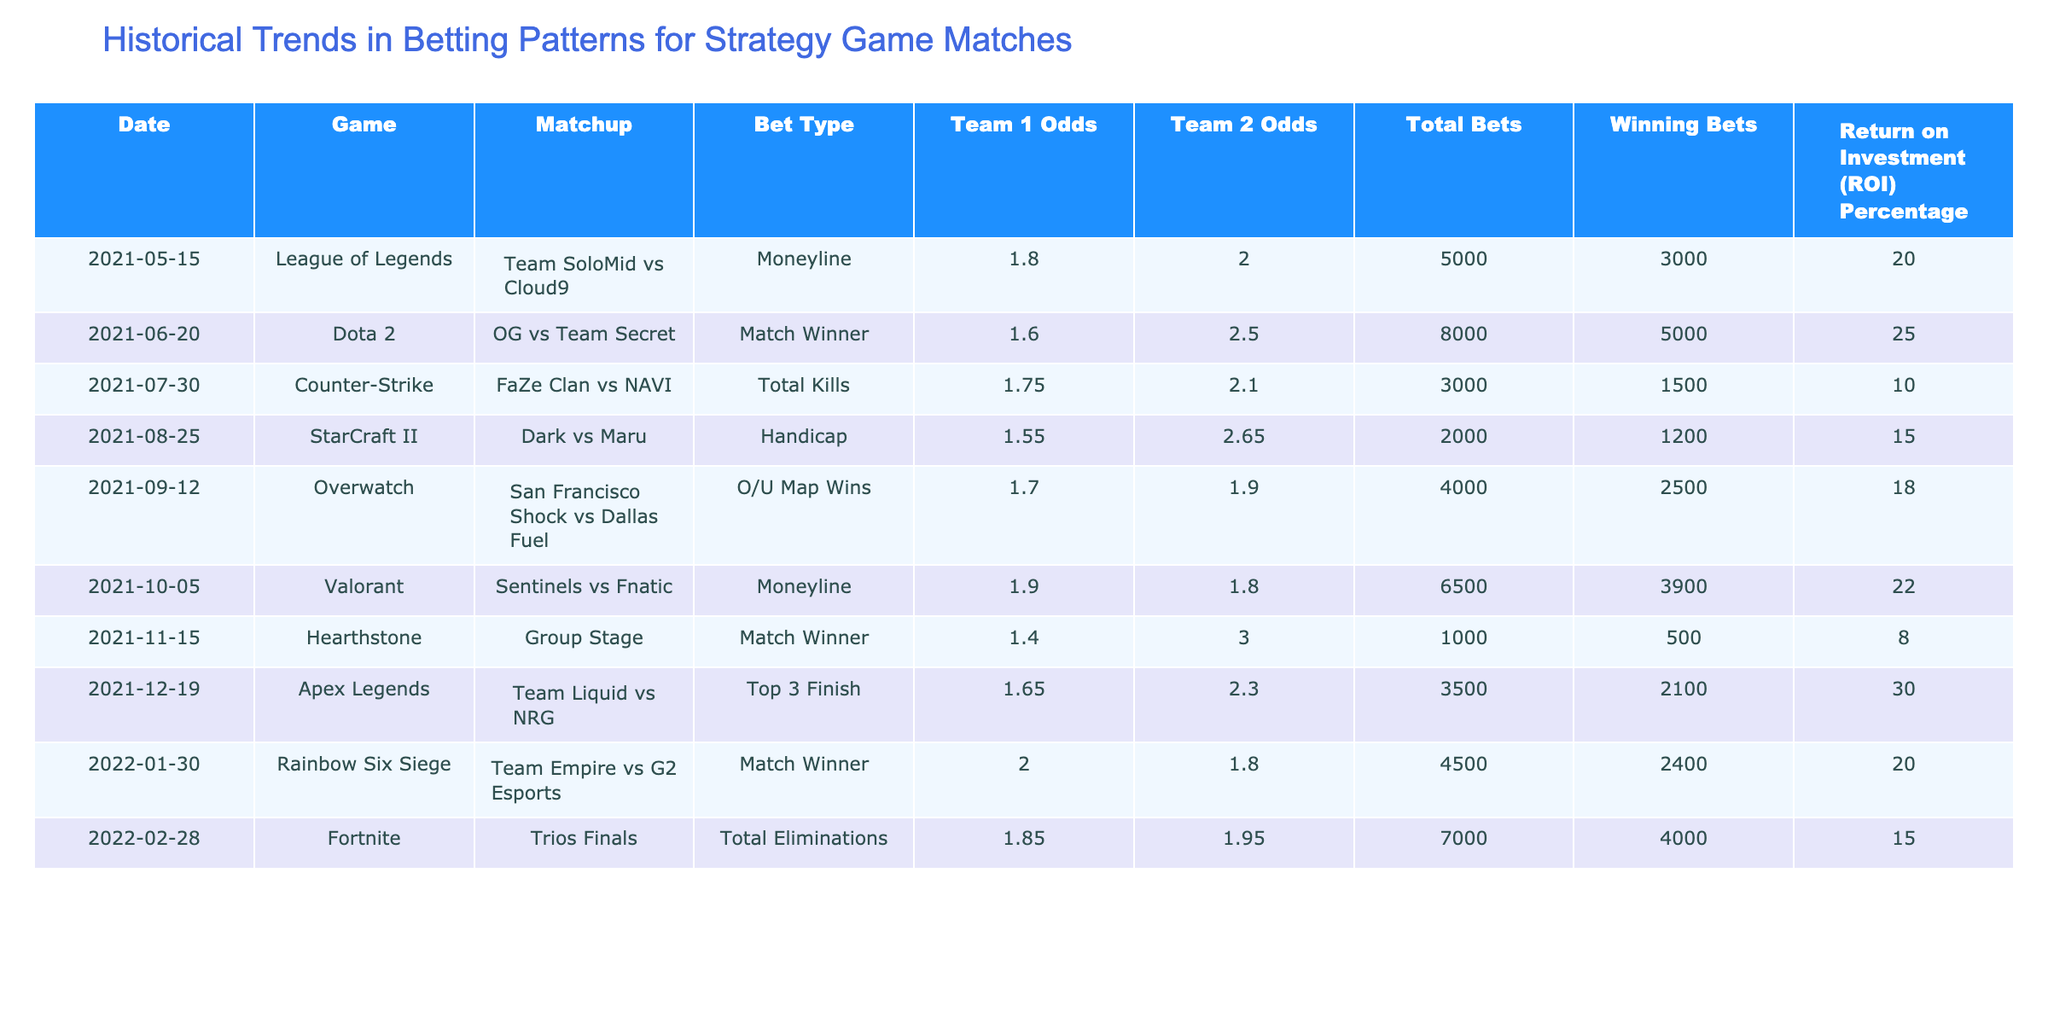What is the ROI percentage for the match between Team SoloMid and Cloud9? The ROI percentage for this match is listed in the table under the respective column, which indicates a value of 20.0%.
Answer: 20.0 Which game had the highest total bets and what was that amount? The highest total bets in the table is found in the Dota 2 match between OG and Team Secret, with an amount of 8000.
Answer: 8000 What is the average ROI percentage for all matches listed in the table? To calculate the average ROI percentage, first, sum the ROI percentages: 20.0 + 25.0 + 10.0 + 15.0 + 18.0 + 22.0 + 8.0 + 30.0 + 20.0 + 15.0 =  243.0. Then divide this sum by the number of matches (10): 243.0 / 10 = 24.3.
Answer: 24.3 Did Team Liquid have the highest ROI percentage among the matches? By checking the ROI percentages of all matches, Team Liquid had an ROI of 30.0%, which is indeed the highest among all matches listed.
Answer: Yes What was the total number of winning bets for the Counter-Strike match between FaZe Clan and NAVI? Referring to the table, the winning bets for this match are listed as 1500 in the corresponding row.
Answer: 1500 Which team had the lowest odds in their matchup and what were the odds? The match with the lowest odds is Hearthstone's Group Stage match with Team 1's odds of 1.40.
Answer: 1.40 How many matches had an ROI percentage greater than 20%? By scanning the ROI percentages, three matches had an ROI greater than 20%: Dota 2 with 25.0%, Valorant with 22.0%, and Apex Legends with 30.0%.
Answer: 3 What is the difference between the total bets for the match between Dark and Maru and the one for San Francisco Shock vs Dallas Fuel? For Dark vs Maru, total bets are 2000, and for the Overwatch match, total bets are 4000. The difference is calculated as 4000 - 2000 = 2000.
Answer: 2000 Is it true that the match on January 30, 2022, had Team 1's odds lower than 2.0? Referring to the odds listed for the match on that date, Team 1's odds are 2.0, so it is not lower.
Answer: No 